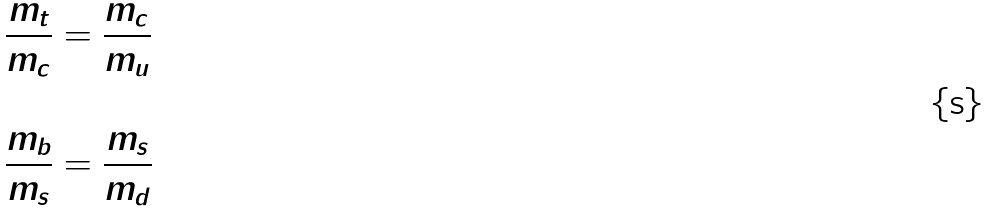Convert formula to latex. <formula><loc_0><loc_0><loc_500><loc_500>& \frac { m _ { t } } { m _ { c } } = \frac { m _ { c } } { m _ { u } } \\ & \\ & \frac { m _ { b } } { m _ { s } } = \frac { m _ { s } } { m _ { d } } \\</formula> 